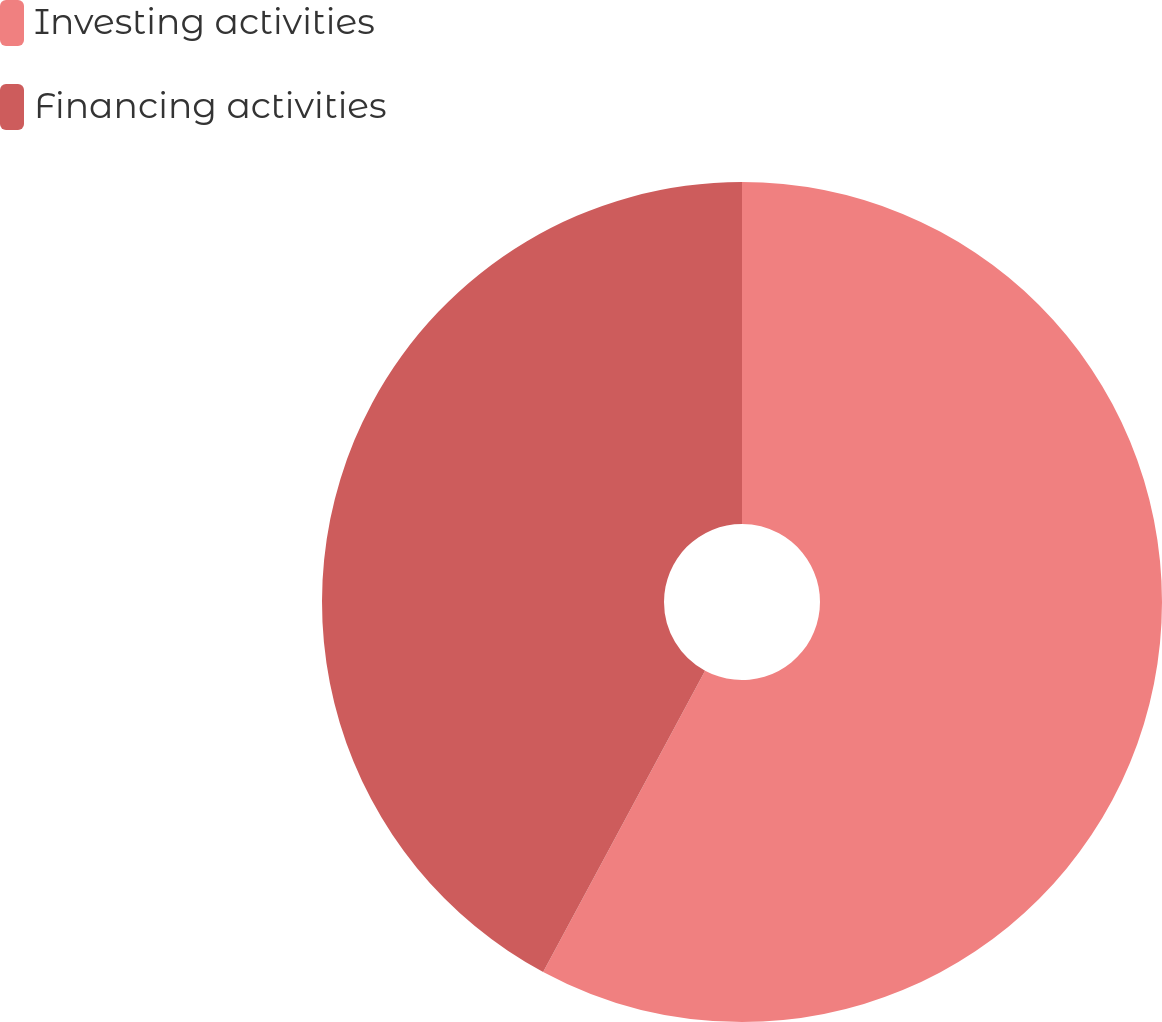<chart> <loc_0><loc_0><loc_500><loc_500><pie_chart><fcel>Investing activities<fcel>Financing activities<nl><fcel>57.85%<fcel>42.15%<nl></chart> 